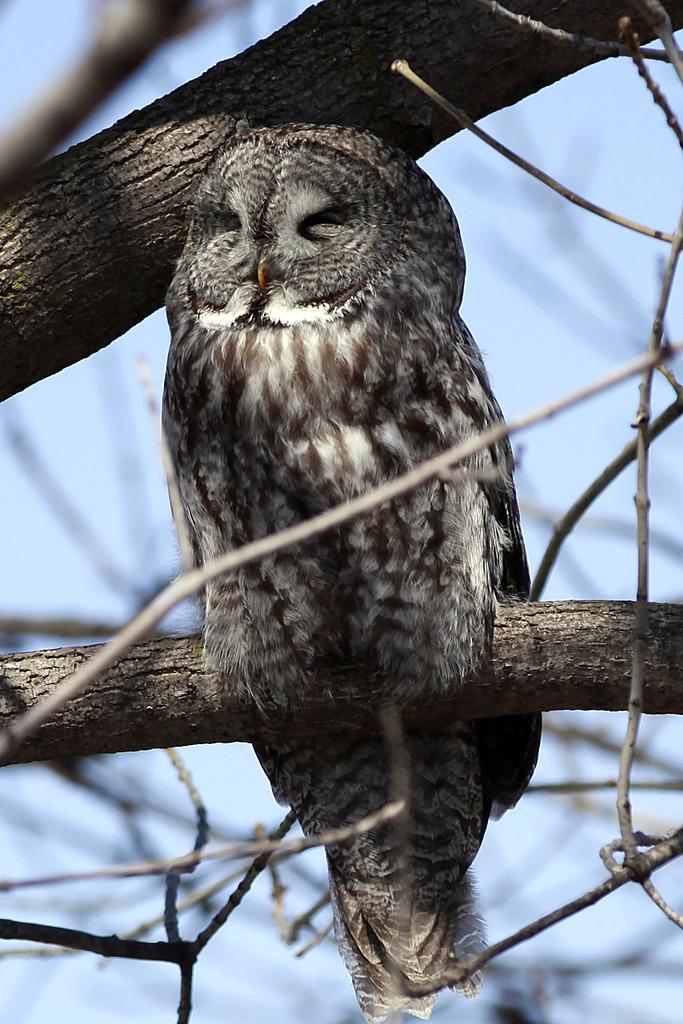What animal is present in the image? There is an owl in the image. Where is the owl located? The owl is on the branch of a tree. What can be seen in the background of the image? The sky is visible in the image. What part of the owl's son is visible in the image? There is no mention of a son or any part of a son in the image, as it only features an owl on a tree branch. 